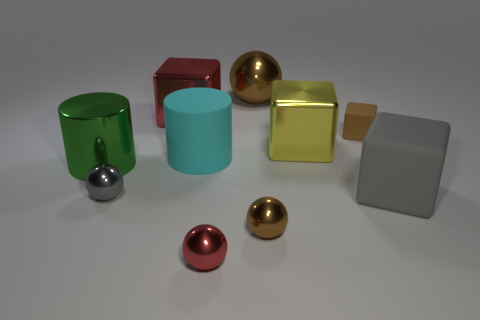Subtract 1 balls. How many balls are left? 3 Subtract all cubes. How many objects are left? 6 Subtract all large red balls. Subtract all tiny red metallic objects. How many objects are left? 9 Add 4 large red objects. How many large red objects are left? 5 Add 2 small red spheres. How many small red spheres exist? 3 Subtract 1 brown spheres. How many objects are left? 9 